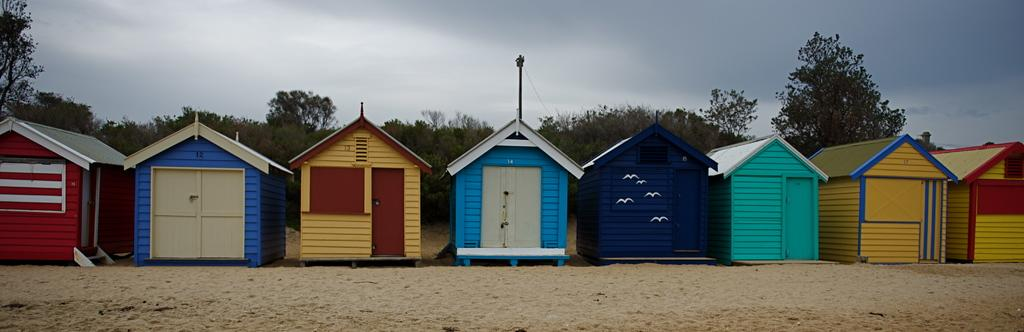What type of structures are visible in the image? There are houses in the image. What can be seen behind the houses? There is a group of trees behind the houses. What is visible at the top of the image? The sky is visible at the top of the image. What type of terrain is visible at the bottom of the image? The sand is visible at the bottom of the image. Where is the throne located in the image? There is no throne present in the image. 